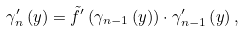<formula> <loc_0><loc_0><loc_500><loc_500>\gamma _ { n } ^ { \prime } \left ( y \right ) = \tilde { f } ^ { \prime } \left ( \gamma _ { n - 1 } \left ( y \right ) \right ) \cdot \gamma _ { n - 1 } ^ { \prime } \left ( y \right ) ,</formula> 